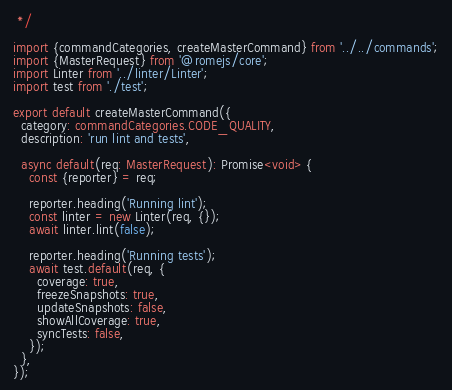Convert code to text. <code><loc_0><loc_0><loc_500><loc_500><_TypeScript_> */

import {commandCategories, createMasterCommand} from '../../commands';
import {MasterRequest} from '@romejs/core';
import Linter from '../linter/Linter';
import test from './test';

export default createMasterCommand({
  category: commandCategories.CODE_QUALITY,
  description: 'run lint and tests',

  async default(req: MasterRequest): Promise<void> {
    const {reporter} = req;

    reporter.heading('Running lint');
    const linter = new Linter(req, {});
    await linter.lint(false);

    reporter.heading('Running tests');
    await test.default(req, {
      coverage: true,
      freezeSnapshots: true,
      updateSnapshots: false,
      showAllCoverage: true,
      syncTests: false,
    });
  },
});
</code> 